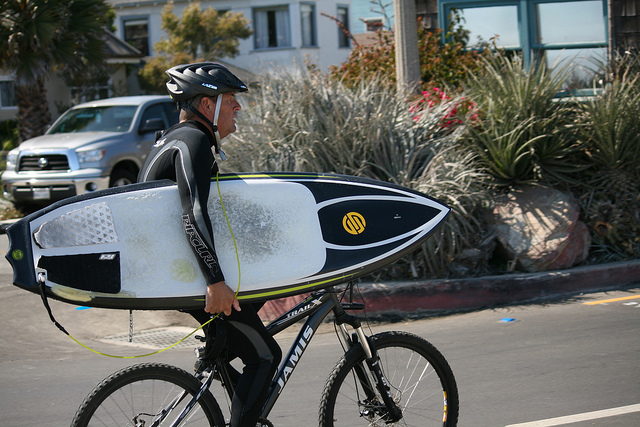Identify the text displayed in this image. JAMIS THANX 